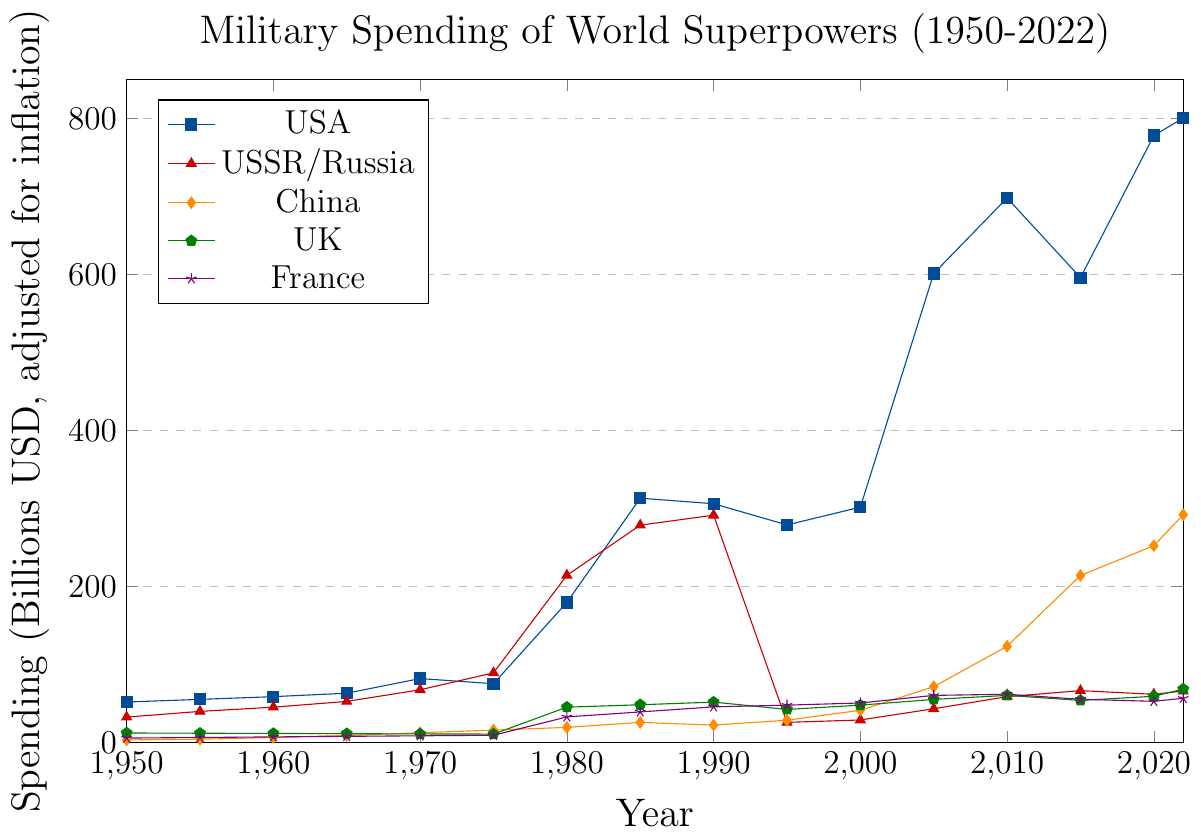Which world superpower had the highest military spending in 2022? The plot shows the spending trends for various superpowers. In 2022, the USA's military spending is represented by the highest point, above all other countries.
Answer: USA By how much did China's military spending increase from 2000 to 2022? To find the increase, subtract China's spending in 2000 from its spending in 2022. In 2000, it was 41.2 billion USD, and in 2022 it was 292 billion USD. So, 292 - 41.2 = 250.8.
Answer: 250.8 billion USD Between which years did the USA see the most significant increase in military spending? Visual inspection of the US line shows the steepest increase between 2000 and 2010, from about 301.7 to 698.2 billion USD. So the increase is 698.2 - 301.7 = 396.5.
Answer: 2000 to 2010 Which country had a higher military spending in 1970, the USSR/Russia or China? Comparing the values on the plot for 1970, the USSR/Russia had 67.5 billion USD, and China had 12.4 billion USD.
Answer: USSR/Russia What is the overall trend in military spending for the UK between 1950 to 2022? Inspecting the line for the UK, the trend shows fluctuations with an overall increase. Early years are nearly flat, a significant rise around the 1980s, slight declines, and another increase towards 2022.
Answer: Increasing with fluctuations Calculate the average military spending of France from 2010 to 2022. Add France's spending for 2010, 2015, 2020, and 2022, then divide by 4. Values are 61.8, 55.3, 52.7, and 56.6. So, (61.8 + 55.3 + 52.7 + 56.6) / 4 = 226.4 / 4 = 56.6.
Answer: 56.6 billion USD How does the military spending of the USSR/Russia in 2022 compare to its peak in 1990? The peak for USSR/Russia was in 1990 at 291.4 billion USD, compared to 65.9 billion USD in 2022. The decline is 291.4 - 65.9 = 225.5.
Answer: Decreased by 225.5 billion USD Which superpower had the smallest increase in military spending from 2005 to 2022? By comparing changes, the UK's increase from 55.2 to 68.4 is 13.2 billion USD, while the increases for other countries are larger.
Answer: UK By what factor did China's military spending increase from 1950 to 2022? Divide China's spending in 2022 (292.0) by its spending in 1950 (3.2). So, 292 / 3.2 = 91.25.
Answer: About 91 How did the military spending of France change from 1980 to 1985? Determine the difference between France's spending in 1985 and 1980 from the plot. The spending in 1980 was 32.7 billion USD and in 1985 was 39.1 billion USD. The change is 39.1 - 32.7 = 6.4.
Answer: Increased by 6.4 billion USD 